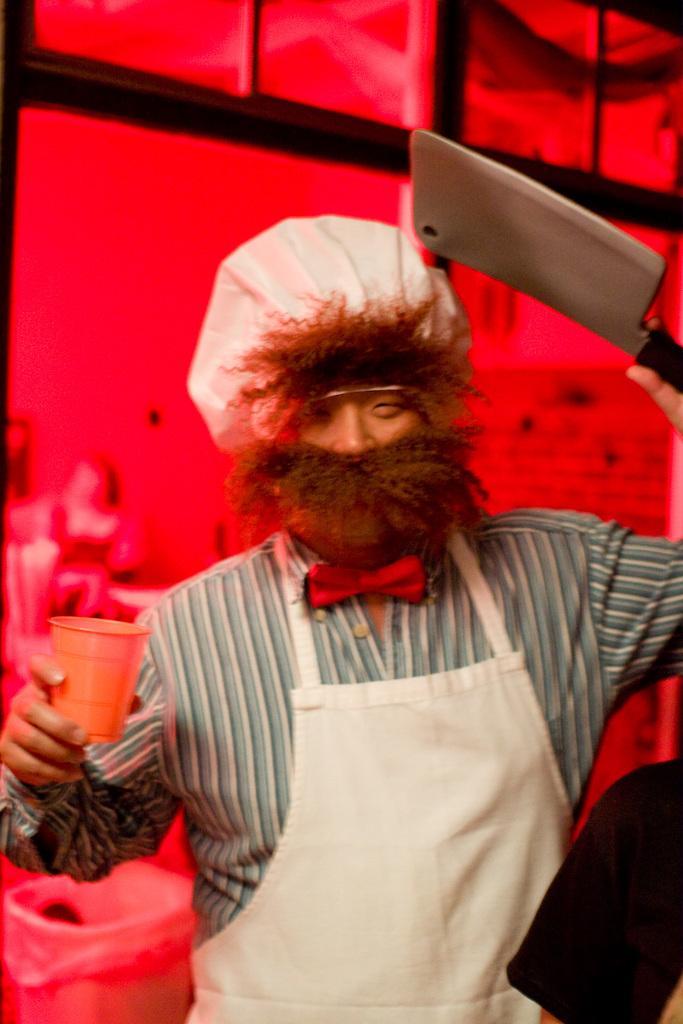Please provide a concise description of this image. In this image we can see a person holding a glass and a knife, behind him there is a dustbin, a photo frame on the wall, the background is red in color. 